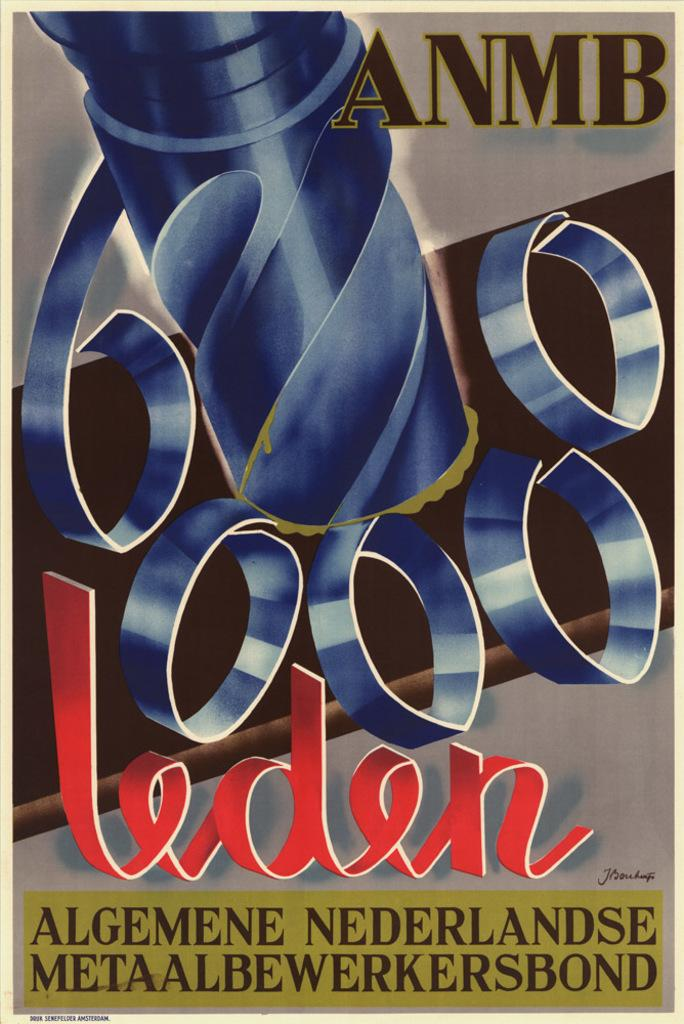Provide a one-sentence caption for the provided image. a poster with the word leden on it. 